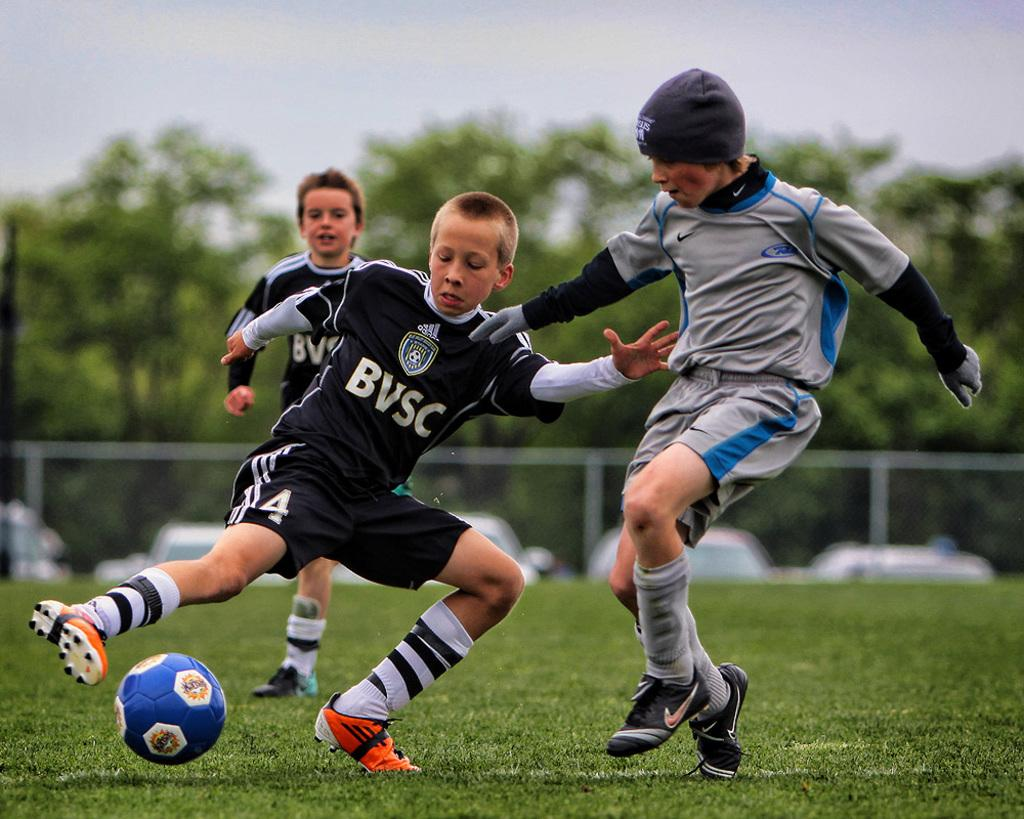How many boys are in the image? There are three boys in the image. What are the boys doing in the image? The boys are on the grass. What are the boys wearing in the image? The boys are wearing jerseys. What object is present in the image that is commonly used in sports? There is a ball in the image. What can be seen in the background of the image? Cars and blurred trees are visible in the background. What type of stone can be seen being used as a whip in the image? There is no stone or whip present in the image. What ingredients can be seen being used to make a stew in the image? There is no stew or ingredients visible in the image. 